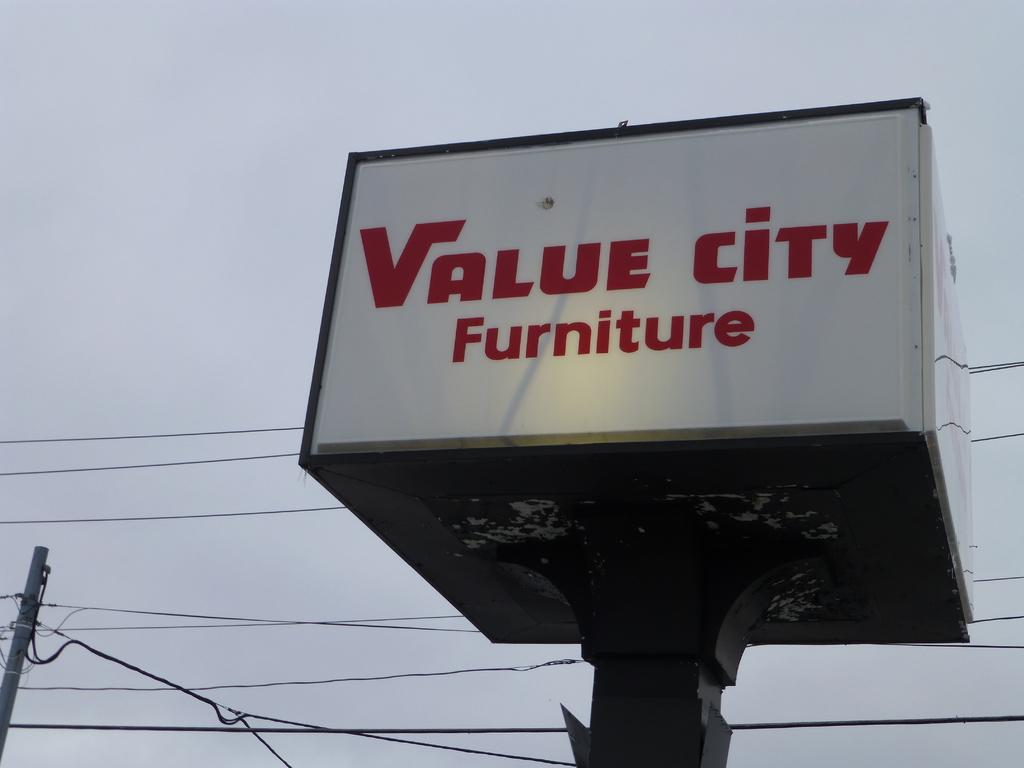<image>
Summarize the visual content of the image. A red and white value city furniture sign. 